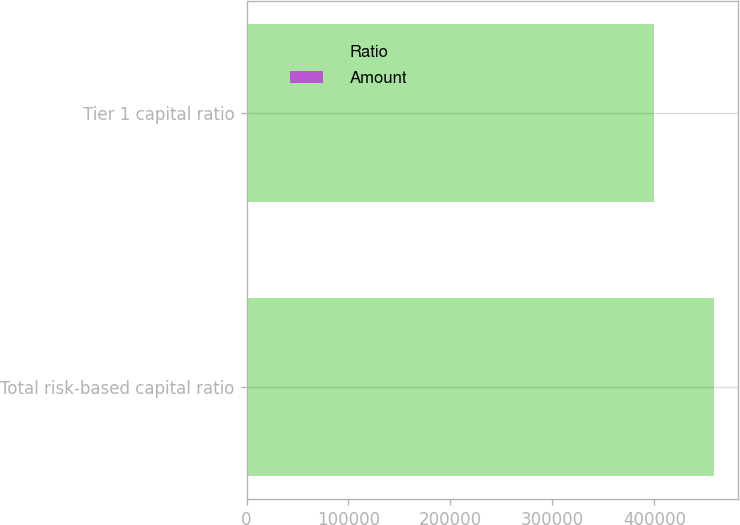Convert chart to OTSL. <chart><loc_0><loc_0><loc_500><loc_500><stacked_bar_chart><ecel><fcel>Total risk-based capital ratio<fcel>Tier 1 capital ratio<nl><fcel>Ratio<fcel>458860<fcel>399187<nl><fcel>Amount<fcel>120.3<fcel>22.8<nl></chart> 